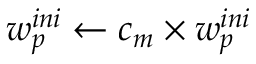<formula> <loc_0><loc_0><loc_500><loc_500>w _ { p } ^ { i n i } \leftarrow c _ { m } \times w _ { p } ^ { i n i }</formula> 